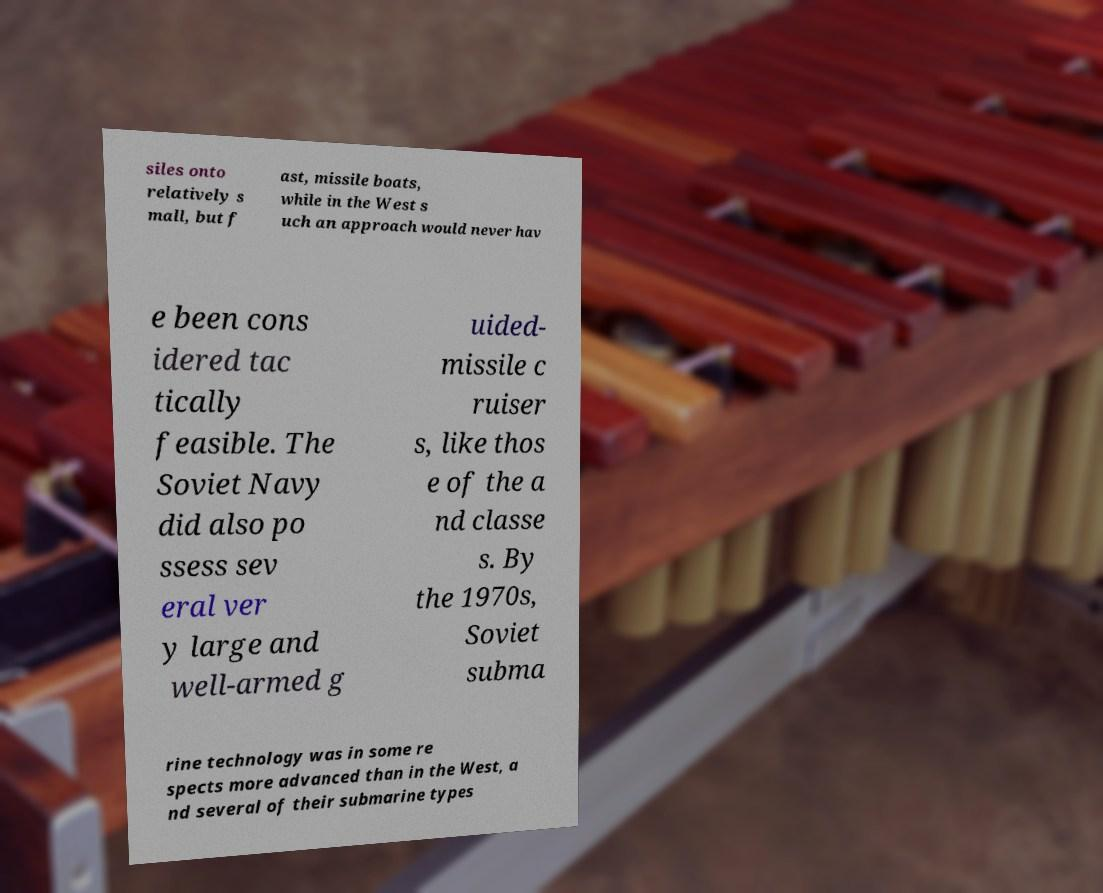What messages or text are displayed in this image? I need them in a readable, typed format. siles onto relatively s mall, but f ast, missile boats, while in the West s uch an approach would never hav e been cons idered tac tically feasible. The Soviet Navy did also po ssess sev eral ver y large and well-armed g uided- missile c ruiser s, like thos e of the a nd classe s. By the 1970s, Soviet subma rine technology was in some re spects more advanced than in the West, a nd several of their submarine types 